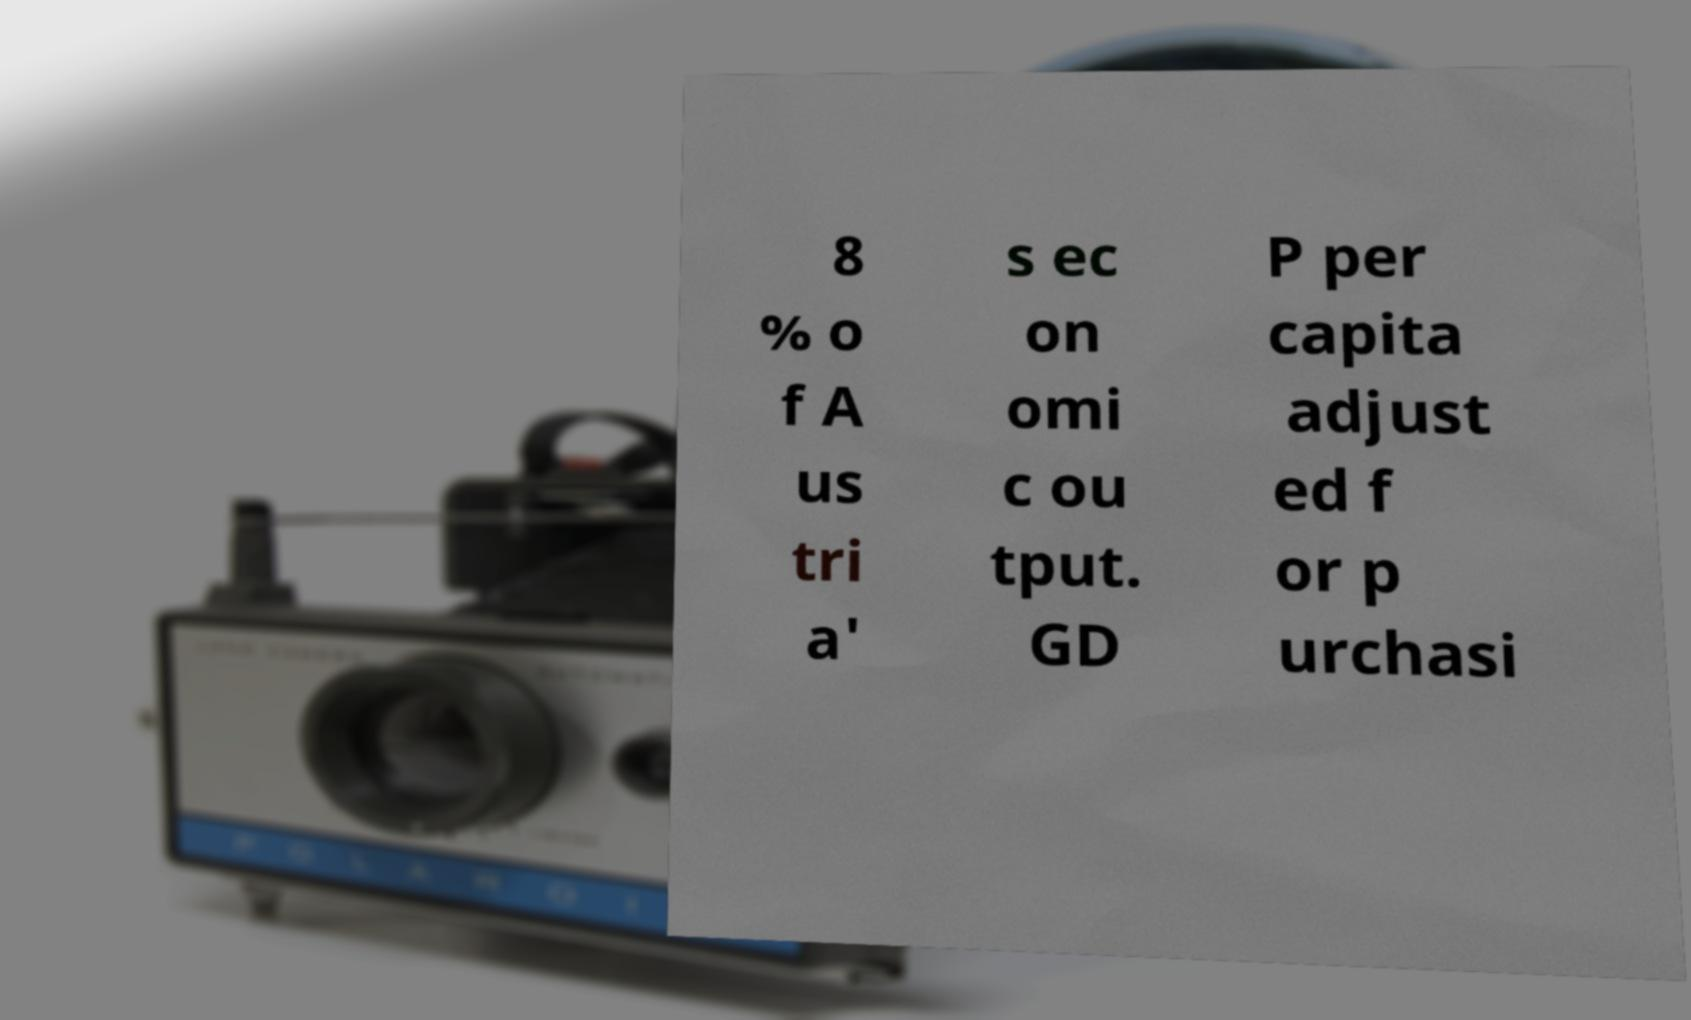Please identify and transcribe the text found in this image. 8 % o f A us tri a' s ec on omi c ou tput. GD P per capita adjust ed f or p urchasi 